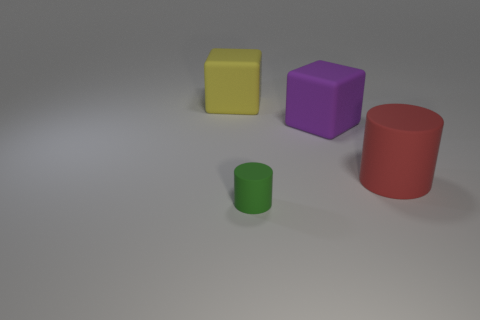What is the size of the other thing that is the same shape as the green thing?
Make the answer very short. Large. Are there any other things that are the same size as the green thing?
Your response must be concise. No. Is the number of rubber objects that are behind the large cylinder greater than the number of yellow rubber cubes that are right of the tiny green matte thing?
Keep it short and to the point. Yes. Do the yellow thing and the red matte cylinder have the same size?
Make the answer very short. Yes. There is a small rubber thing that is the same shape as the large red thing; what color is it?
Your answer should be very brief. Green. How many rubber blocks have the same color as the tiny cylinder?
Your answer should be very brief. 0. Are there more green cylinders that are in front of the large purple thing than large cyan shiny cubes?
Provide a short and direct response. Yes. There is a cylinder left of the big red matte object that is right of the small cylinder; what color is it?
Your response must be concise. Green. How many things are big matte blocks left of the purple rubber block or matte things on the right side of the yellow rubber thing?
Your answer should be compact. 4. The big rubber cylinder is what color?
Ensure brevity in your answer.  Red. 